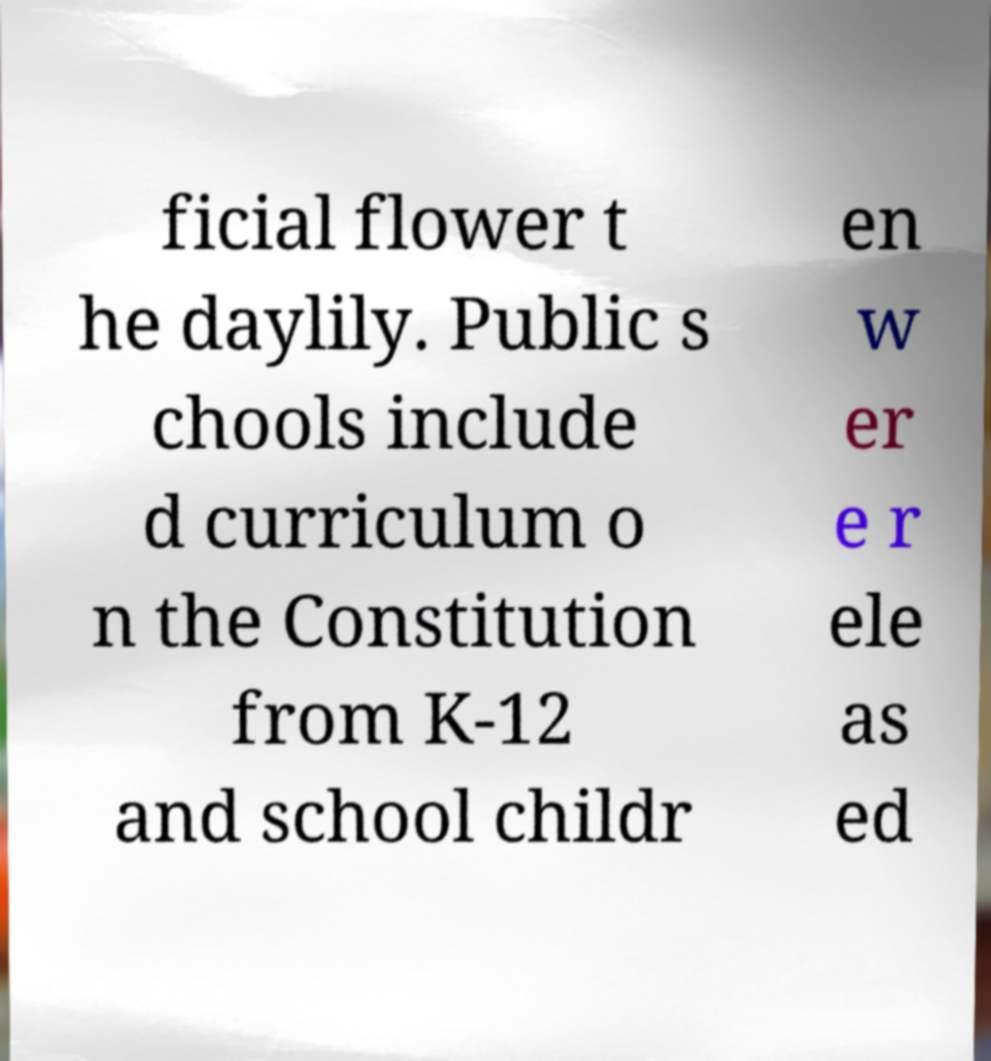Can you accurately transcribe the text from the provided image for me? ficial flower t he daylily. Public s chools include d curriculum o n the Constitution from K-12 and school childr en w er e r ele as ed 